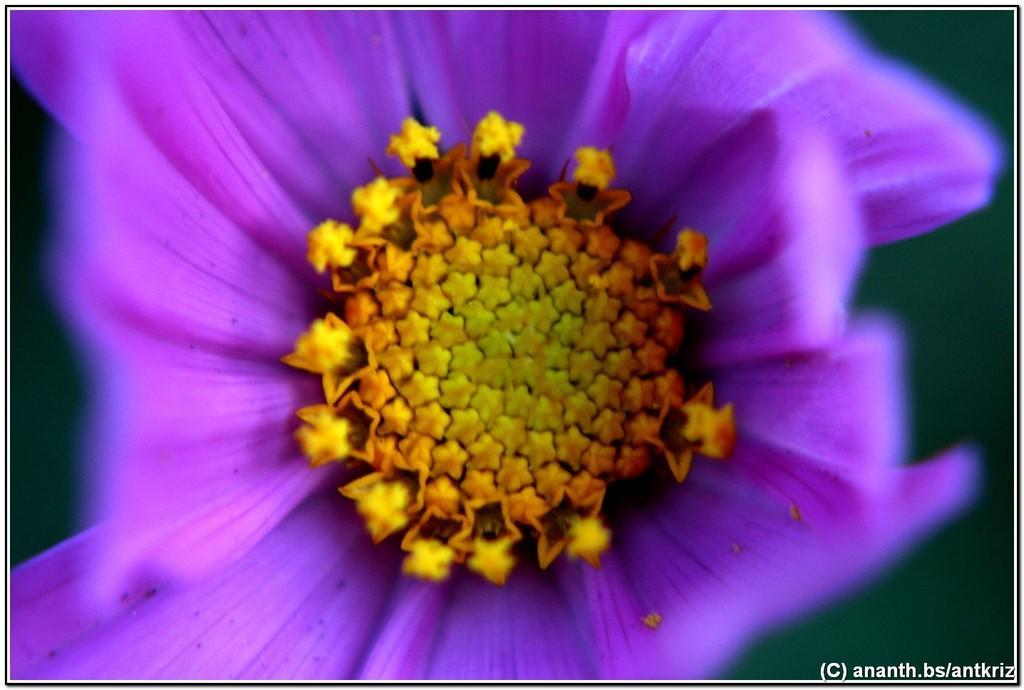Please provide a concise description of this image. In the center of the image there is a flower. At the bottom of the image there is text. 